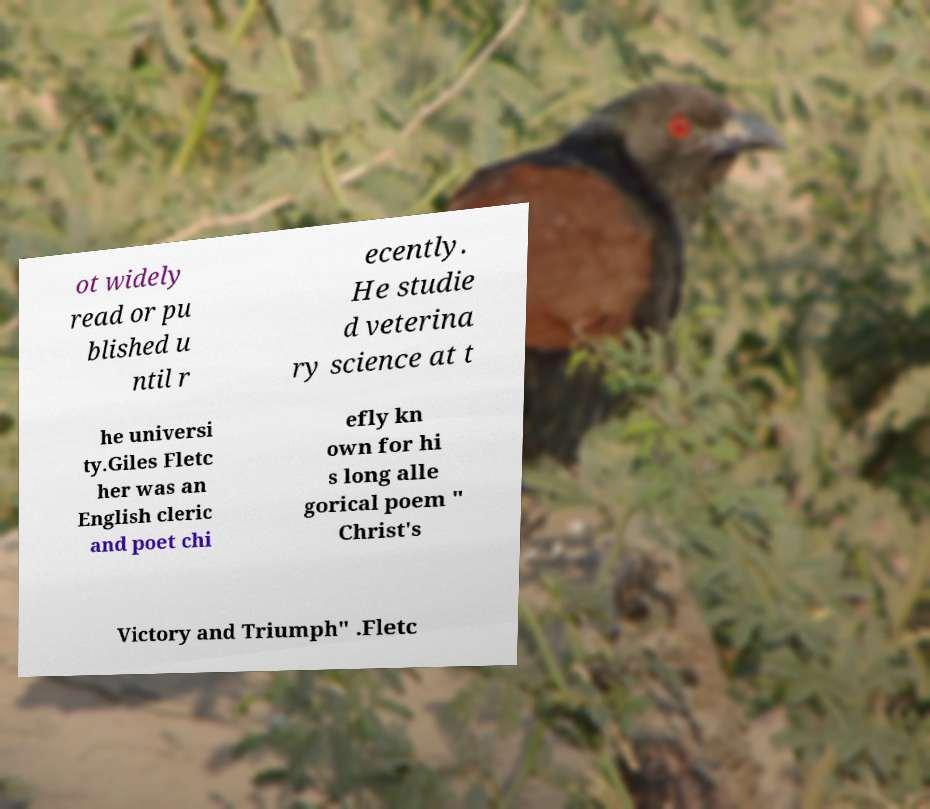I need the written content from this picture converted into text. Can you do that? ot widely read or pu blished u ntil r ecently. He studie d veterina ry science at t he universi ty.Giles Fletc her was an English cleric and poet chi efly kn own for hi s long alle gorical poem " Christ's Victory and Triumph" .Fletc 